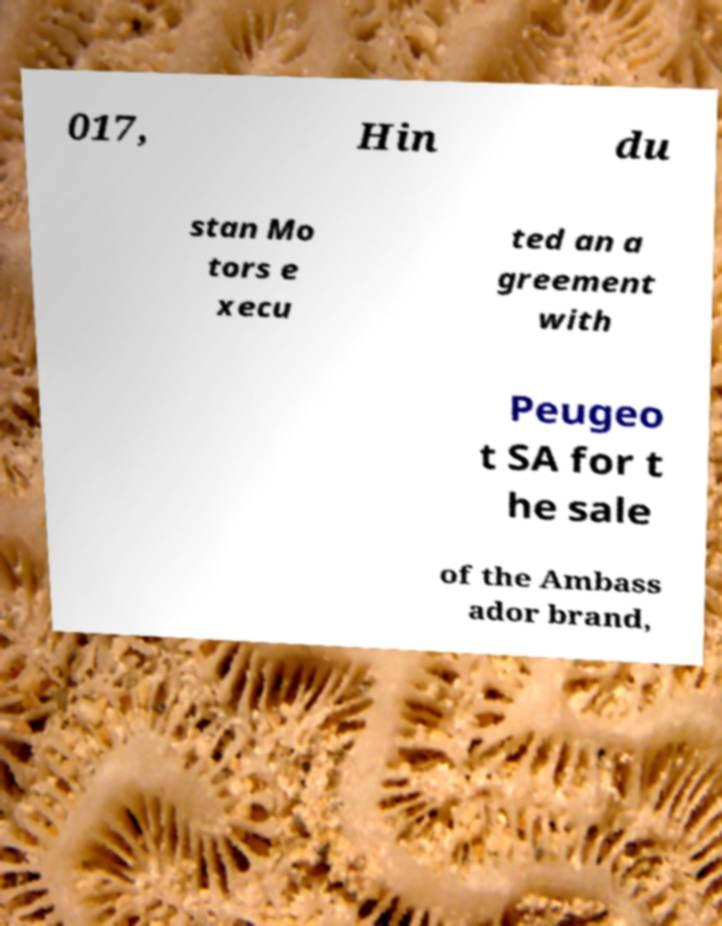Could you assist in decoding the text presented in this image and type it out clearly? 017, Hin du stan Mo tors e xecu ted an a greement with Peugeo t SA for t he sale of the Ambass ador brand, 